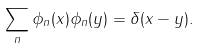Convert formula to latex. <formula><loc_0><loc_0><loc_500><loc_500>\sum _ { n } \phi _ { n } ( x ) \phi _ { n } ( y ) = \delta ( x - y ) .</formula> 